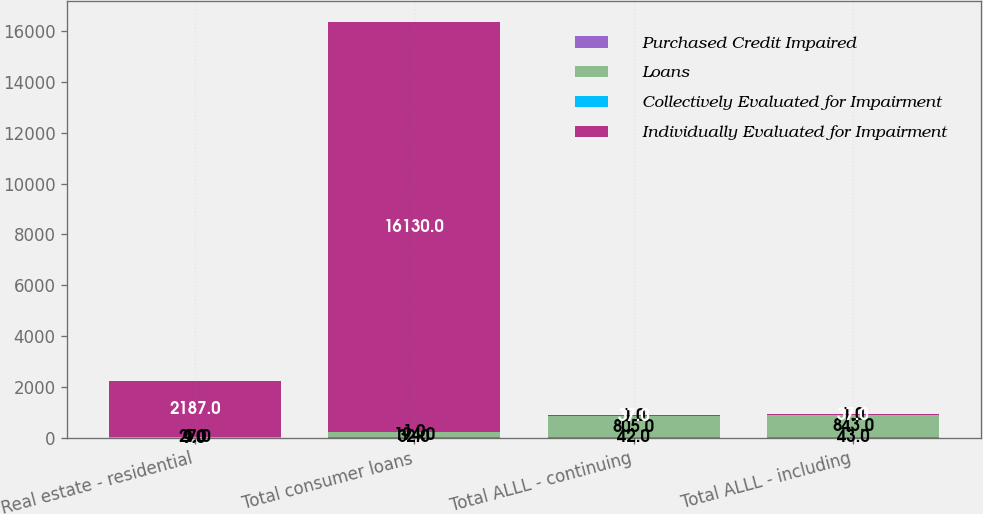<chart> <loc_0><loc_0><loc_500><loc_500><stacked_bar_chart><ecel><fcel>Real estate - residential<fcel>Total consumer loans<fcel>Total ALLL - continuing<fcel>Total ALLL - including<nl><fcel>Purchased Credit Impaired<fcel>9<fcel>32<fcel>42<fcel>43<nl><fcel>Loans<fcel>27<fcel>194<fcel>805<fcel>843<nl><fcel>Collectively Evaluated for Impairment<fcel>1<fcel>1<fcel>1<fcel>1<nl><fcel>Individually Evaluated for Impairment<fcel>2187<fcel>16130<fcel>37<fcel>37<nl></chart> 